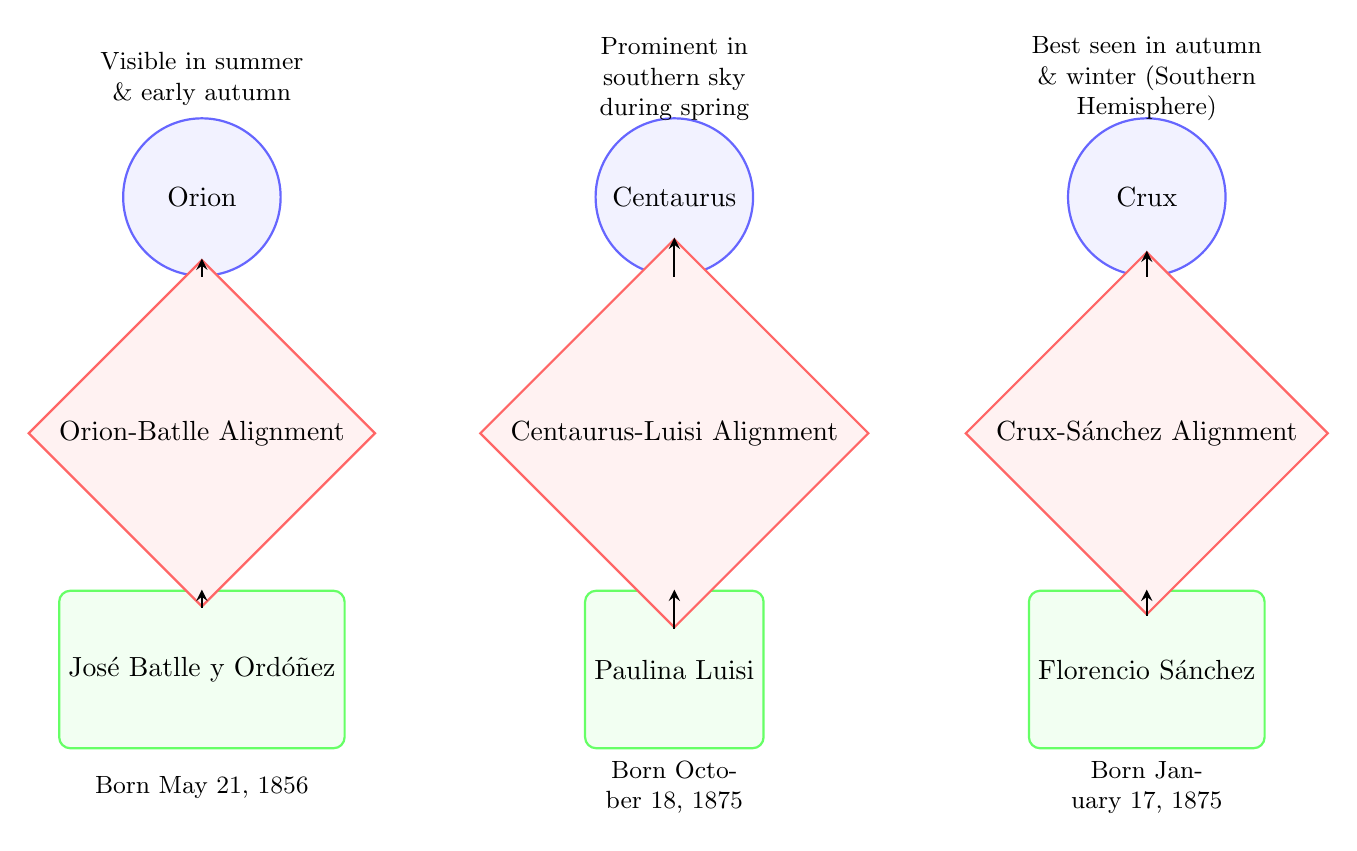What is the constellation associated with José Batlle y Ordóñez? In the diagram, José Batlle y Ordóñez is connected to the event labeled "Orion-Batlle Alignment," which indicates that the constellation associated with him is Orion.
Answer: Orion Which constellation is prominent in the southern sky during spring? The diagram states that Centaurus is the constellation that is "Prominent in southern sky during spring." This is indicated in the label directly above the Centaurus node.
Answer: Centaurus How many events are represented in the diagram? The diagram shows three events: "Orion-Batlle Alignment," "Centaurus-Luisi Alignment," and "Crux-Sánchez Alignment." Counting these gives a total of three events.
Answer: 3 What birthdate is associated with Paulina Luisi? The diagram indicates that Paulina Luisi was born on October 18, 1875, which is stated directly under her node.
Answer: October 18, 1875 Which constellation is aligned with Florencio Sánchez? The diagram indicates that Florencio Sánchez is connected to "Crux-Sánchez Alignment," revealing that the constellation associated with him is Crux.
Answer: Crux What is the relationship between Orion and José Batlle y Ordóñez? The relationship shown in the diagram is that Orion is connected to the event "Orion-Batlle Alignment," which then connects to José Batlle y Ordóñez, indicating a direct association.
Answer: Alignment How many constellations are depicted in the diagram? The diagram features three constellations, namely Orion, Centaurus, and Crux, which can be counted directly from the nodes at the top.
Answer: 3 Which person is aligned with the constellation Crux? The event labeled "Crux-Sánchez Alignment" connects the constellation Crux directly to the person Florencio Sánchez, indicating that he is aligned with this constellation.
Answer: Florencio Sánchez What notable figure was born in 1856? The diagram shows José Batlle y Ordóñez with the birthdate May 21, 1856, positioned directly below his node. This indicates he is the notable figure born in that year.
Answer: José Batlle y Ordóñez 